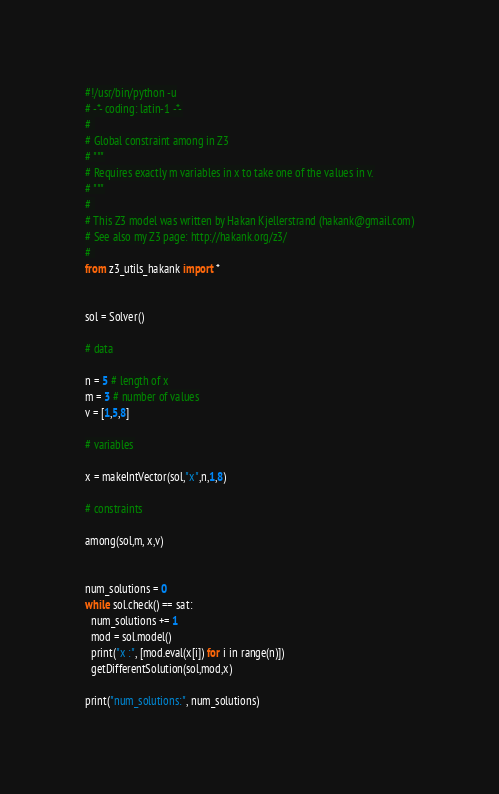Convert code to text. <code><loc_0><loc_0><loc_500><loc_500><_Python_>#!/usr/bin/python -u
# -*- coding: latin-1 -*-
# 
# Global constraint among in Z3
# """
# Requires exactly m variables in x to take one of the values in v.
# """
# 
# This Z3 model was written by Hakan Kjellerstrand (hakank@gmail.com)
# See also my Z3 page: http://hakank.org/z3/
# 
from z3_utils_hakank import *


sol = Solver()

# data

n = 5 # length of x
m = 3 # number of values
v = [1,5,8]

# variables

x = makeIntVector(sol,"x",n,1,8)

# constraints

among(sol,m, x,v)


num_solutions = 0
while sol.check() == sat:
  num_solutions += 1
  mod = sol.model()
  print("x :", [mod.eval(x[i]) for i in range(n)])
  getDifferentSolution(sol,mod,x)

print("num_solutions:", num_solutions)
</code> 